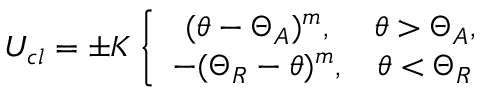Convert formula to latex. <formula><loc_0><loc_0><loc_500><loc_500>U _ { c l } = \pm K \left \{ \begin{array} { c c } { ( \theta - \Theta _ { A } ) ^ { m } , } & { \theta > \Theta _ { A } , } \\ { - ( \Theta _ { R } - \theta ) ^ { m } , } & { \theta < \Theta _ { R } } \end{array}</formula> 